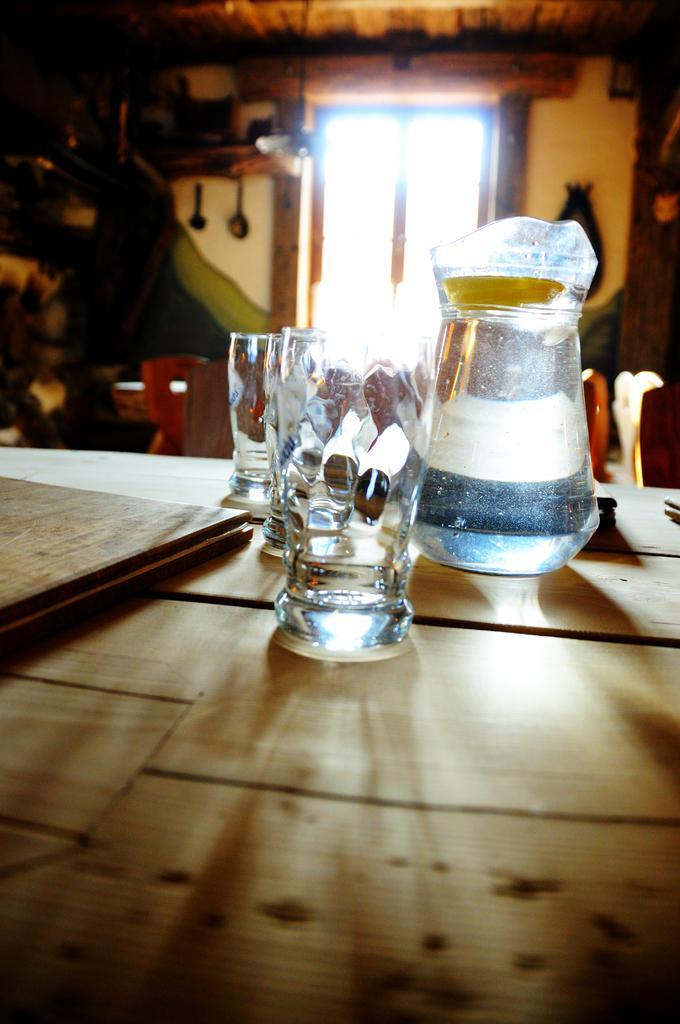Can you describe this image briefly? In this image in the middle there is a table o that there is a glass,book and jar. In the background there is a window and wall. 